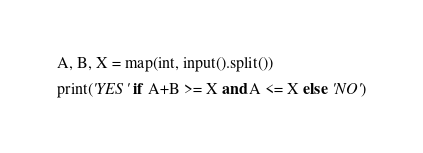Convert code to text. <code><loc_0><loc_0><loc_500><loc_500><_Python_>A, B, X = map(int, input().split())

print('YES' if A+B >= X and A <= X else 'NO')</code> 